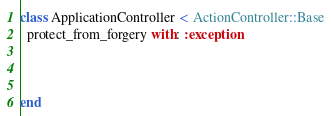Convert code to text. <code><loc_0><loc_0><loc_500><loc_500><_Ruby_>class ApplicationController < ActionController::Base
  protect_from_forgery with: :exception


  
end
</code> 